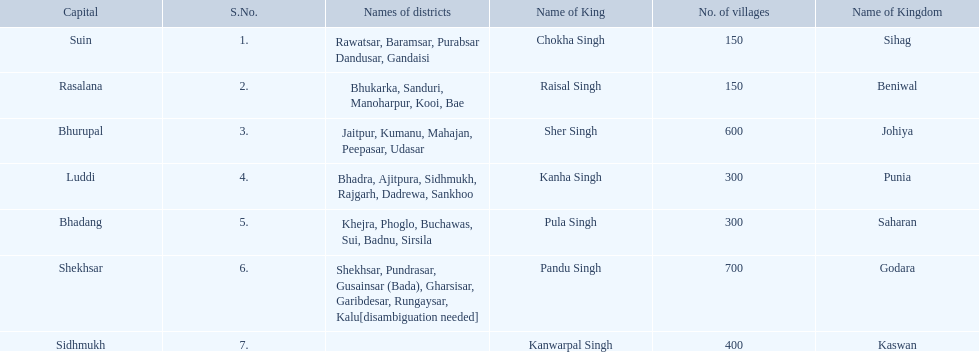Does punia have more or less villages than godara? Less. 